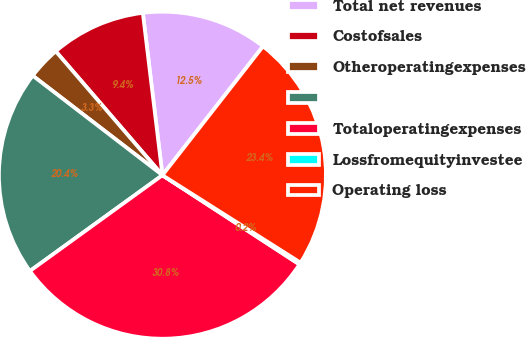<chart> <loc_0><loc_0><loc_500><loc_500><pie_chart><fcel>Total net revenues<fcel>Costofsales<fcel>Otheroperatingexpenses<fcel>Unnamed: 3<fcel>Totaloperatingexpenses<fcel>Lossfromequityinvestee<fcel>Operating loss<nl><fcel>12.46%<fcel>9.4%<fcel>3.27%<fcel>20.38%<fcel>30.85%<fcel>0.2%<fcel>23.44%<nl></chart> 